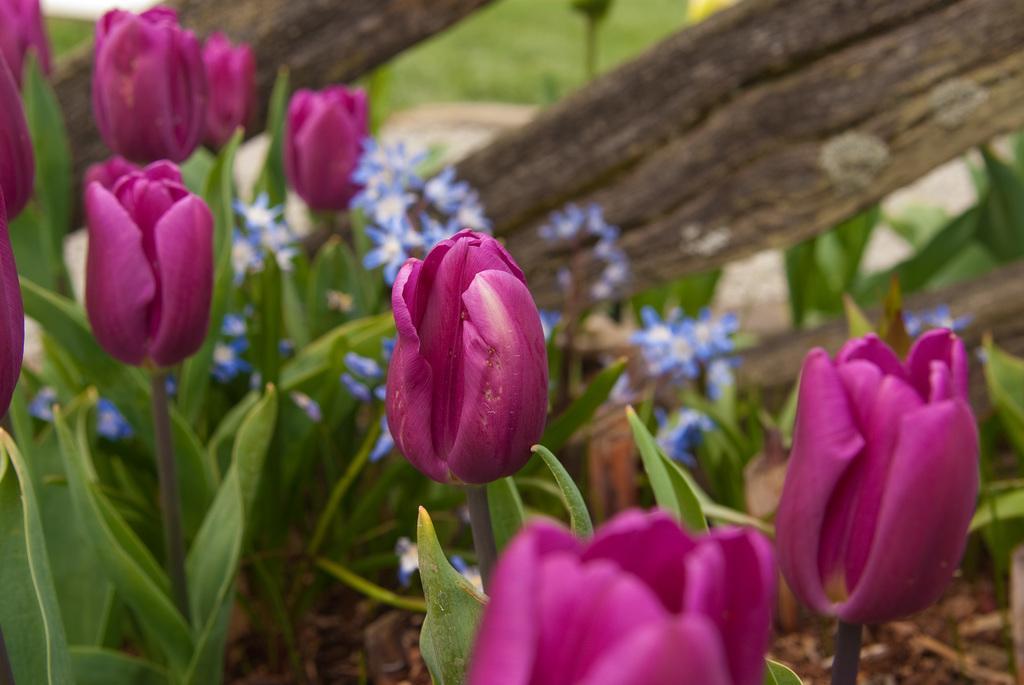Describe this image in one or two sentences. In this image there are flowers and leaves, behind the flowers there is a wooden fence. 